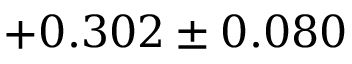<formula> <loc_0><loc_0><loc_500><loc_500>+ 0 . 3 0 2 \pm 0 . 0 8 0</formula> 